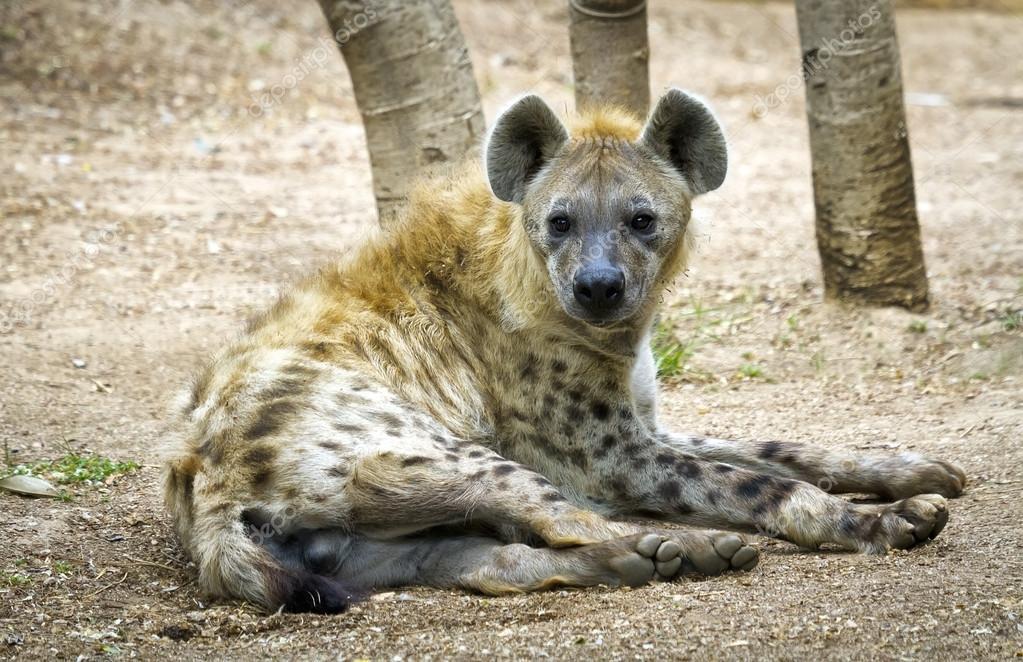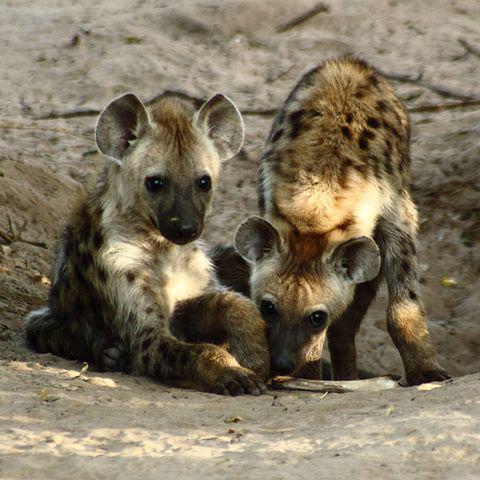The first image is the image on the left, the second image is the image on the right. Evaluate the accuracy of this statement regarding the images: "The combined images contain a total of four hyenas, including at least one hyena pup posed with its parent.". Is it true? Answer yes or no. No. The first image is the image on the left, the second image is the image on the right. Assess this claim about the two images: "A single animal stands in one of the images, while an animal lies on the ground in the other.". Correct or not? Answer yes or no. No. 